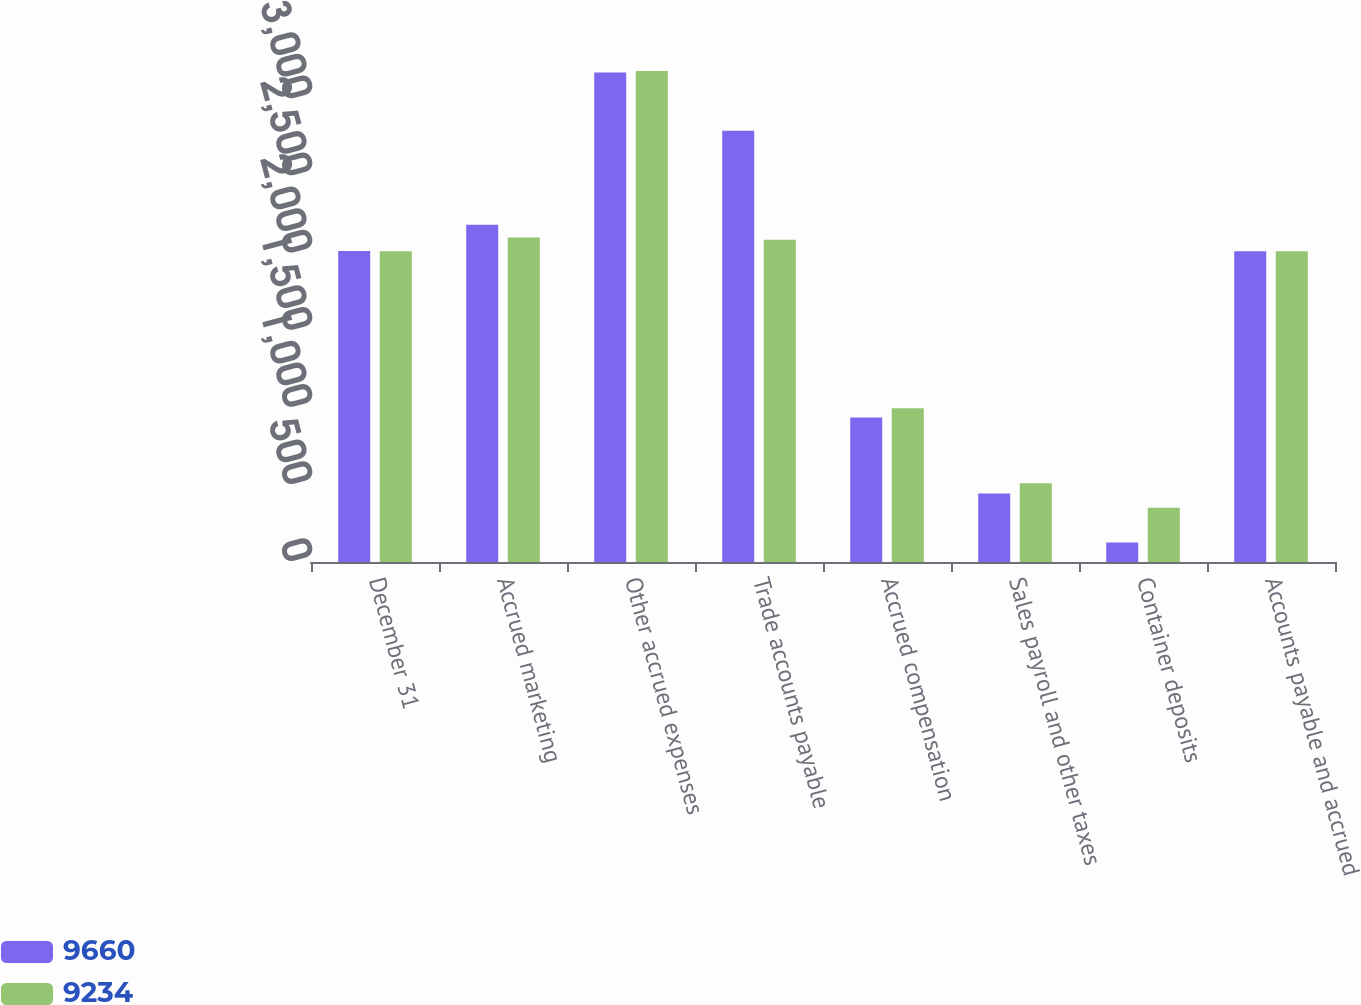Convert chart to OTSL. <chart><loc_0><loc_0><loc_500><loc_500><stacked_bar_chart><ecel><fcel>December 31<fcel>Accrued marketing<fcel>Other accrued expenses<fcel>Trade accounts payable<fcel>Accrued compensation<fcel>Sales payroll and other taxes<fcel>Container deposits<fcel>Accounts payable and accrued<nl><fcel>9660<fcel>2015<fcel>2186<fcel>3173<fcel>2795<fcel>936<fcel>444<fcel>126<fcel>2014.5<nl><fcel>9234<fcel>2014<fcel>2103<fcel>3182<fcel>2089<fcel>997<fcel>511<fcel>352<fcel>2014.5<nl></chart> 